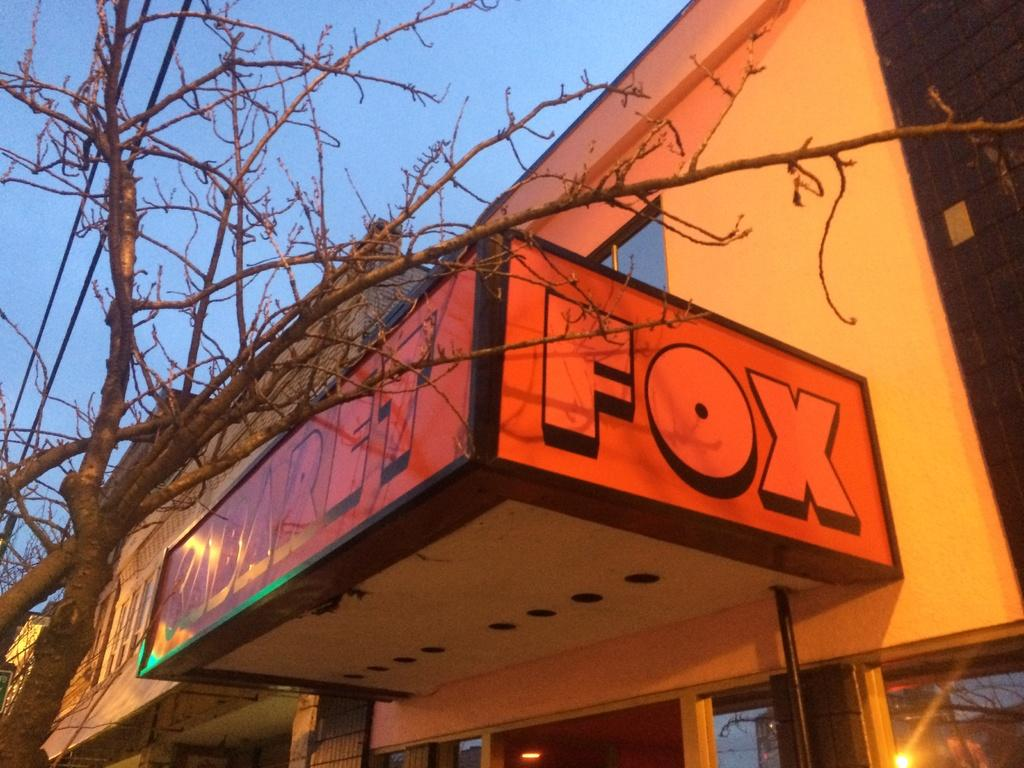What is on the board that is visible in the image? There is a board with writing in the image. What type of structures can be seen in the image? There are buildings in the image. What type of vegetation is present in the image? There are trees in the image. What type of windows are visible in the image? Glass windows are visible in the image. What can be seen through the windows? Light is visible through the windows. What is visible in the background of the image? The sky is visible in the background of the image. How many cows are grazing in the background of the image? There are no cows present in the image; it features a board with writing, buildings, trees, glass windows, and the sky. What type of activity is taking place during the recess in the image? There is no indication of a recess or any specific activity taking place in the image. 